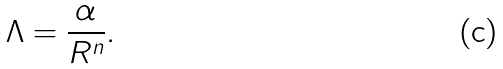Convert formula to latex. <formula><loc_0><loc_0><loc_500><loc_500>\Lambda = \frac { \alpha } { R ^ { n } } .</formula> 